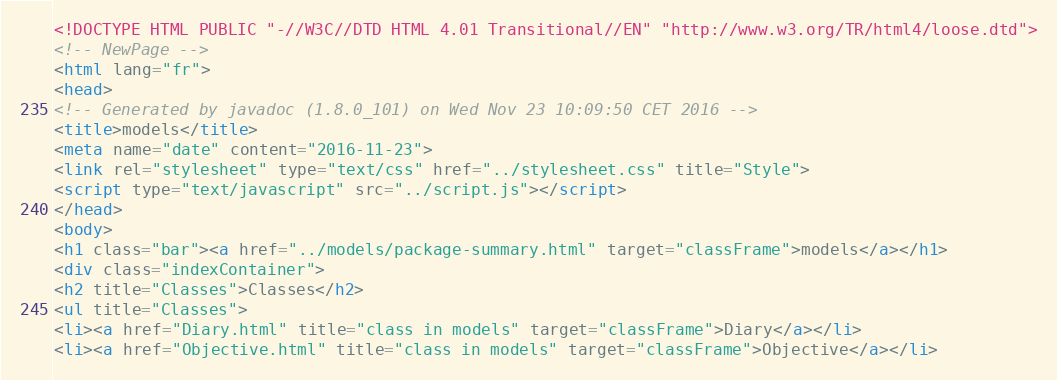<code> <loc_0><loc_0><loc_500><loc_500><_HTML_><!DOCTYPE HTML PUBLIC "-//W3C//DTD HTML 4.01 Transitional//EN" "http://www.w3.org/TR/html4/loose.dtd">
<!-- NewPage -->
<html lang="fr">
<head>
<!-- Generated by javadoc (1.8.0_101) on Wed Nov 23 10:09:50 CET 2016 -->
<title>models</title>
<meta name="date" content="2016-11-23">
<link rel="stylesheet" type="text/css" href="../stylesheet.css" title="Style">
<script type="text/javascript" src="../script.js"></script>
</head>
<body>
<h1 class="bar"><a href="../models/package-summary.html" target="classFrame">models</a></h1>
<div class="indexContainer">
<h2 title="Classes">Classes</h2>
<ul title="Classes">
<li><a href="Diary.html" title="class in models" target="classFrame">Diary</a></li>
<li><a href="Objective.html" title="class in models" target="classFrame">Objective</a></li></code> 